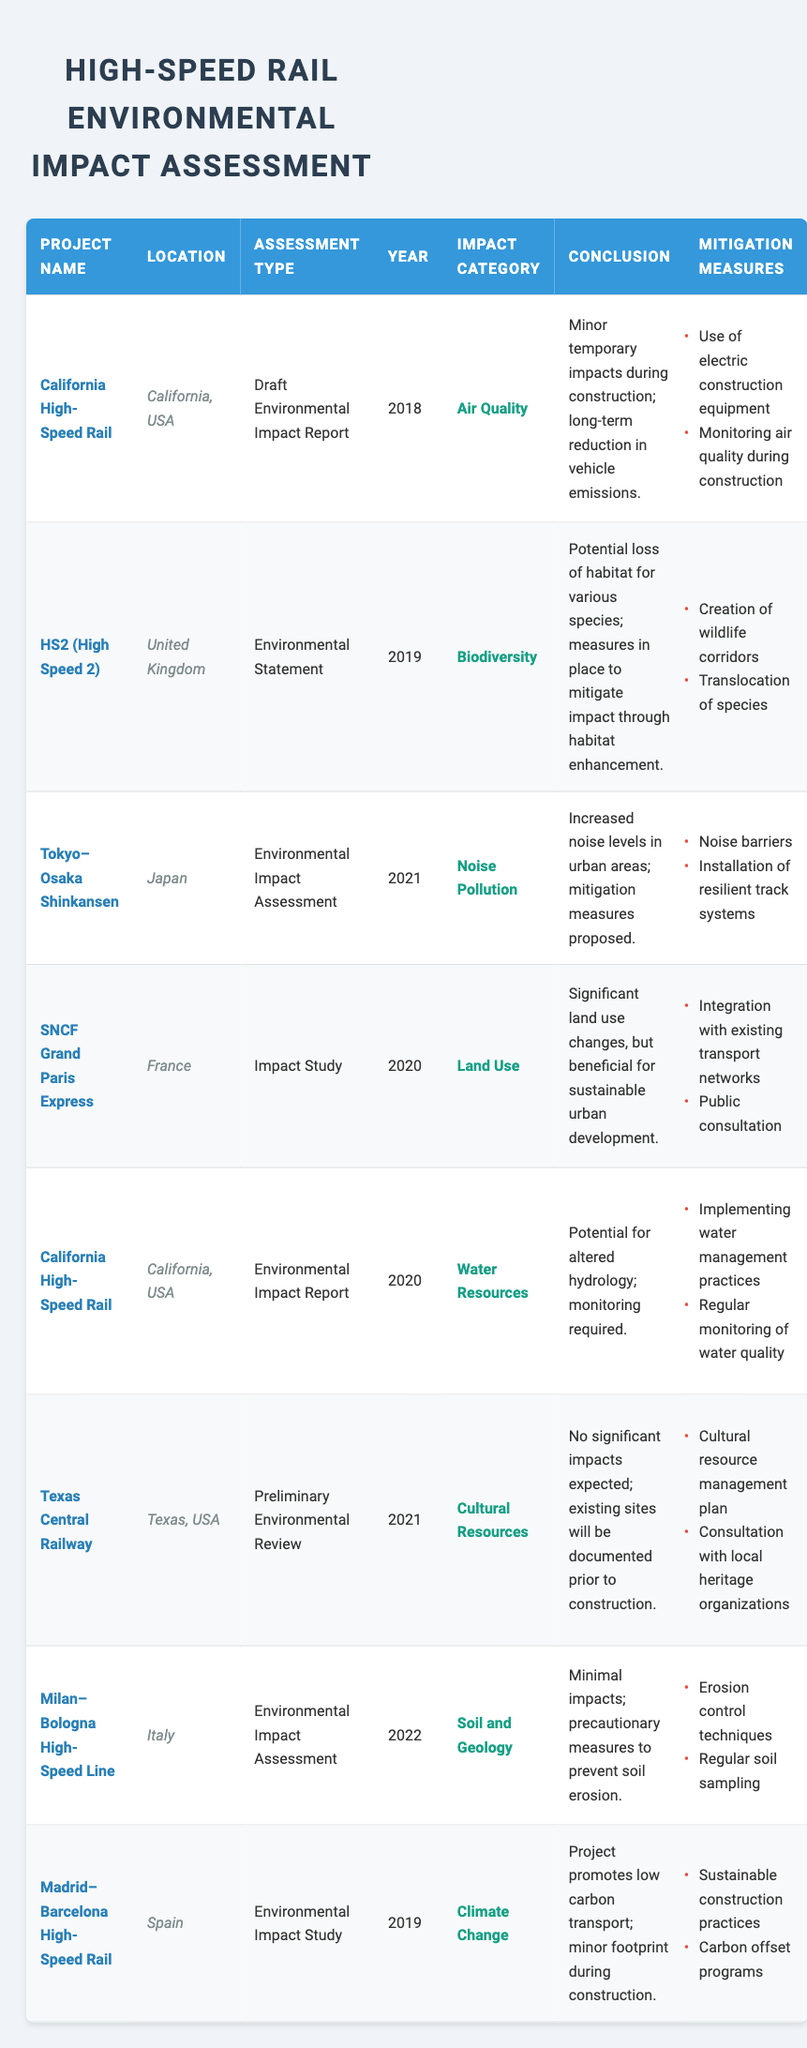What is the conclusion for the California High-Speed Rail project regarding air quality? The conclusion for this project can be found in the row corresponding to the California High-Speed Rail and the Air Quality impact category. It states that there are "Minor temporary impacts during construction; long-term reduction in vehicle emissions."
Answer: Minor temporary impacts during construction; long-term reduction in vehicle emissions Which project had a mitigation measure for creating wildlife corridors? By examining the impact category of each project, the one that addresses biodiversity, specifically mentions "Creation of wildlife corridors" as a mitigation measure. This is found in the HS2 (High Speed 2) project in the United Kingdom.
Answer: HS2 (High Speed 2) What is the conclusion concerning soil and geology for the Milan–Bologna High-Speed Line? Looking at the specific row for the Milan–Bologna High-Speed Line under the Soil and Geology category reveals the conclusion states "Minimal impacts; precautionary measures to prevent soil erosion."
Answer: Minimal impacts; precautionary measures to prevent soil erosion Which mitigation measure is common between the California High-Speed Rail water resources assessment and the SNCF Grand Paris Express land use assessment? The mitigation measure of "Regular monitoring" is common in the context of the California High-Speed Rail which monitors water quality, while the SNCF Grand Paris Express has a focus on public consultation for land use. Only the California project mentions monitoring but it provides a focus on preventing environmental impacts more broadly.
Answer: No common mitigation measure How many different years are represented in the assessments? The years across the assessments are 2018, 2019, 2020, 2021, and 2022. Counting these distinct years gives us a total of five different years.
Answer: 5 Is it true that all projects mention measures to mitigate noise pollution? Examining the table, only the Tokyo–Osaka Shinkansen specifically addresses noise pollution, while the other projects focus on different impact categories. Thus, it is false that all projects mention noise mitigation measures.
Answer: No Which project assessment was conducted in 2021 and involves cultural resources? The Texas Central Railway is the project listed with an assessment year of 2021 and it involves cultural resources, as indicated in the relevant row of the table.
Answer: Texas Central Railway What percentage of the listed projects included an assessment type classified as an Environmental Impact Report? There are two projects (California High-Speed Rail in 2018 and California High-Speed Rail in 2020) with an assessment type of Environmental Impact Report out of a total of eight projects. So the percentage is (2/8) * 100 = 25%.
Answer: 25% Which country had the most recent environmental impact assessment based on the table? By analyzing the years listed alongside the project names, the most recent environmental impact assessment is for the Milan–Bologna High-Speed Line in Italy, which was assessed in 2022.
Answer: Italy 